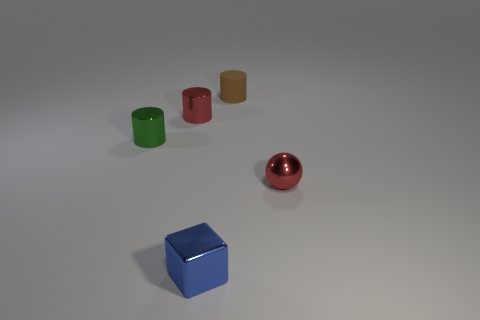There is a cylinder that is the same color as the ball; what is it made of?
Your response must be concise. Metal. How many other things are there of the same color as the tiny sphere?
Offer a terse response. 1. Are there any other things that have the same material as the small blue thing?
Provide a succinct answer. Yes. Is the rubber object the same color as the ball?
Your response must be concise. No. What is the shape of the small red object that is made of the same material as the red cylinder?
Your answer should be very brief. Sphere. How many red shiny objects have the same shape as the brown matte object?
Your answer should be very brief. 1. There is a red metal thing that is to the left of the tiny blue shiny block that is in front of the matte cylinder; what shape is it?
Provide a succinct answer. Cylinder. Is the size of the shiny thing in front of the metal ball the same as the matte cylinder?
Provide a short and direct response. Yes. There is a metallic object that is both right of the small green shiny cylinder and on the left side of the tiny blue shiny object; how big is it?
Your response must be concise. Small. What number of blue metallic cubes have the same size as the rubber object?
Offer a terse response. 1. 